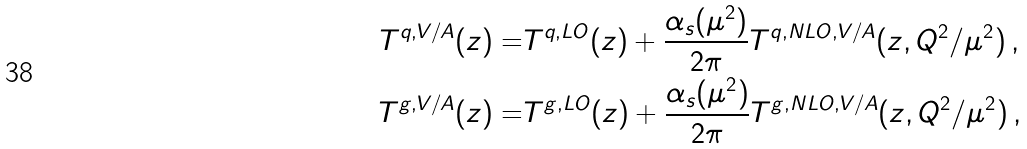Convert formula to latex. <formula><loc_0><loc_0><loc_500><loc_500>T ^ { q , V / A } ( z ) = & T ^ { q , L O } ( z ) + \frac { \alpha _ { s } ( \mu ^ { 2 } ) } { 2 \pi } T ^ { q , N L O , V / A } ( z , Q ^ { 2 } / \mu ^ { 2 } ) \, , \\ T ^ { g , V / A } ( z ) = & T ^ { g , L O } ( z ) + \frac { \alpha _ { s } ( \mu ^ { 2 } ) } { 2 \pi } T ^ { g , N L O , V / A } ( z , Q ^ { 2 } / \mu ^ { 2 } ) \, ,</formula> 